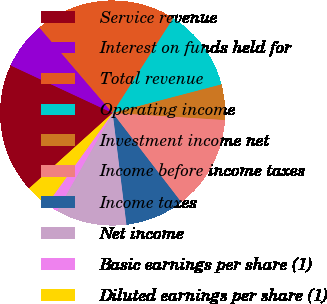Convert chart to OTSL. <chart><loc_0><loc_0><loc_500><loc_500><pie_chart><fcel>Service revenue<fcel>Interest on funds held for<fcel>Total revenue<fcel>Operating income<fcel>Investment income net<fcel>Income before income taxes<fcel>Income taxes<fcel>Net income<fcel>Basic earnings per share (1)<fcel>Diluted earnings per share (1)<nl><fcel>18.64%<fcel>6.78%<fcel>20.33%<fcel>11.86%<fcel>5.09%<fcel>13.56%<fcel>8.48%<fcel>10.17%<fcel>1.7%<fcel>3.4%<nl></chart> 